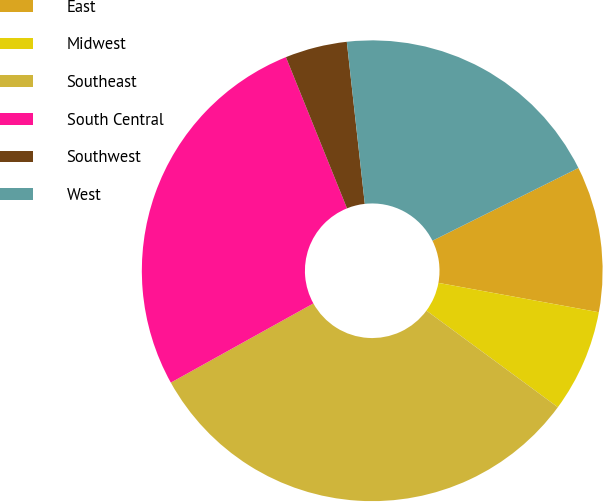<chart> <loc_0><loc_0><loc_500><loc_500><pie_chart><fcel>East<fcel>Midwest<fcel>Southeast<fcel>South Central<fcel>Southwest<fcel>West<nl><fcel>10.24%<fcel>7.21%<fcel>31.84%<fcel>26.96%<fcel>4.35%<fcel>19.4%<nl></chart> 